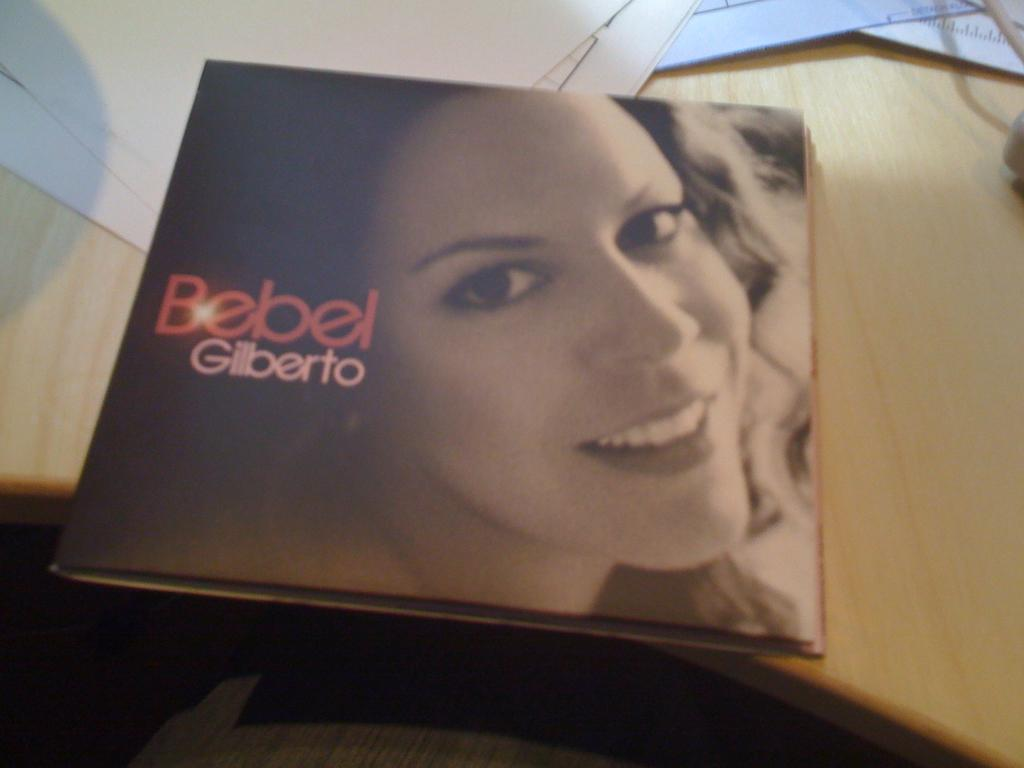What object is on the table in the image? There is a book on the table in the image. What can be seen on the cover page of the book? The cover page of the book features a woman's face. Is there any text on the cover page of the book? Yes, there is text on the cover page of the book. What else is on the table in the image besides the book? There are other papers on the table in the image. What type of bottle is on the ground in the image? There is no bottle present in the image; it only features a book and papers on a table. 